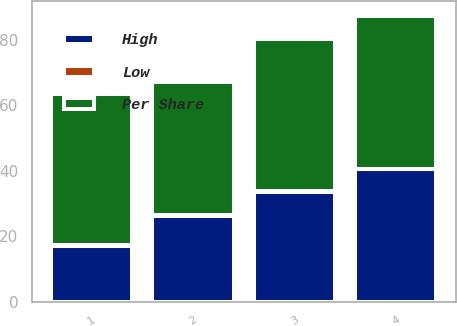Convert chart. <chart><loc_0><loc_0><loc_500><loc_500><stacked_bar_chart><ecel><fcel>1<fcel>2<fcel>3<fcel>4<nl><fcel>Per Share<fcel>46.32<fcel>40.62<fcel>46.4<fcel>46.77<nl><fcel>High<fcel>17.06<fcel>26.21<fcel>33.53<fcel>40.42<nl><fcel>Low<fcel>0.14<fcel>0.14<fcel>0.14<fcel>0.14<nl></chart> 